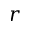<formula> <loc_0><loc_0><loc_500><loc_500>r</formula> 